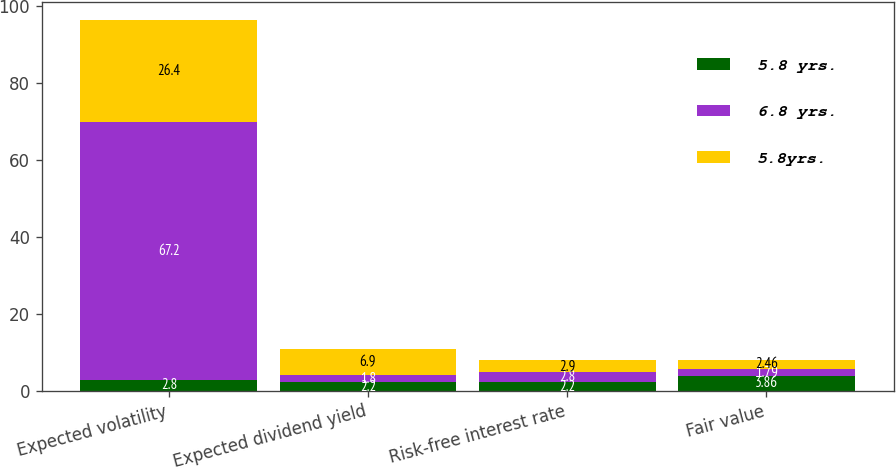Convert chart to OTSL. <chart><loc_0><loc_0><loc_500><loc_500><stacked_bar_chart><ecel><fcel>Expected volatility<fcel>Expected dividend yield<fcel>Risk-free interest rate<fcel>Fair value<nl><fcel>5.8 yrs.<fcel>2.8<fcel>2.2<fcel>2.2<fcel>3.86<nl><fcel>6.8 yrs.<fcel>67.2<fcel>1.8<fcel>2.8<fcel>1.79<nl><fcel>5.8yrs.<fcel>26.4<fcel>6.9<fcel>2.9<fcel>2.46<nl></chart> 